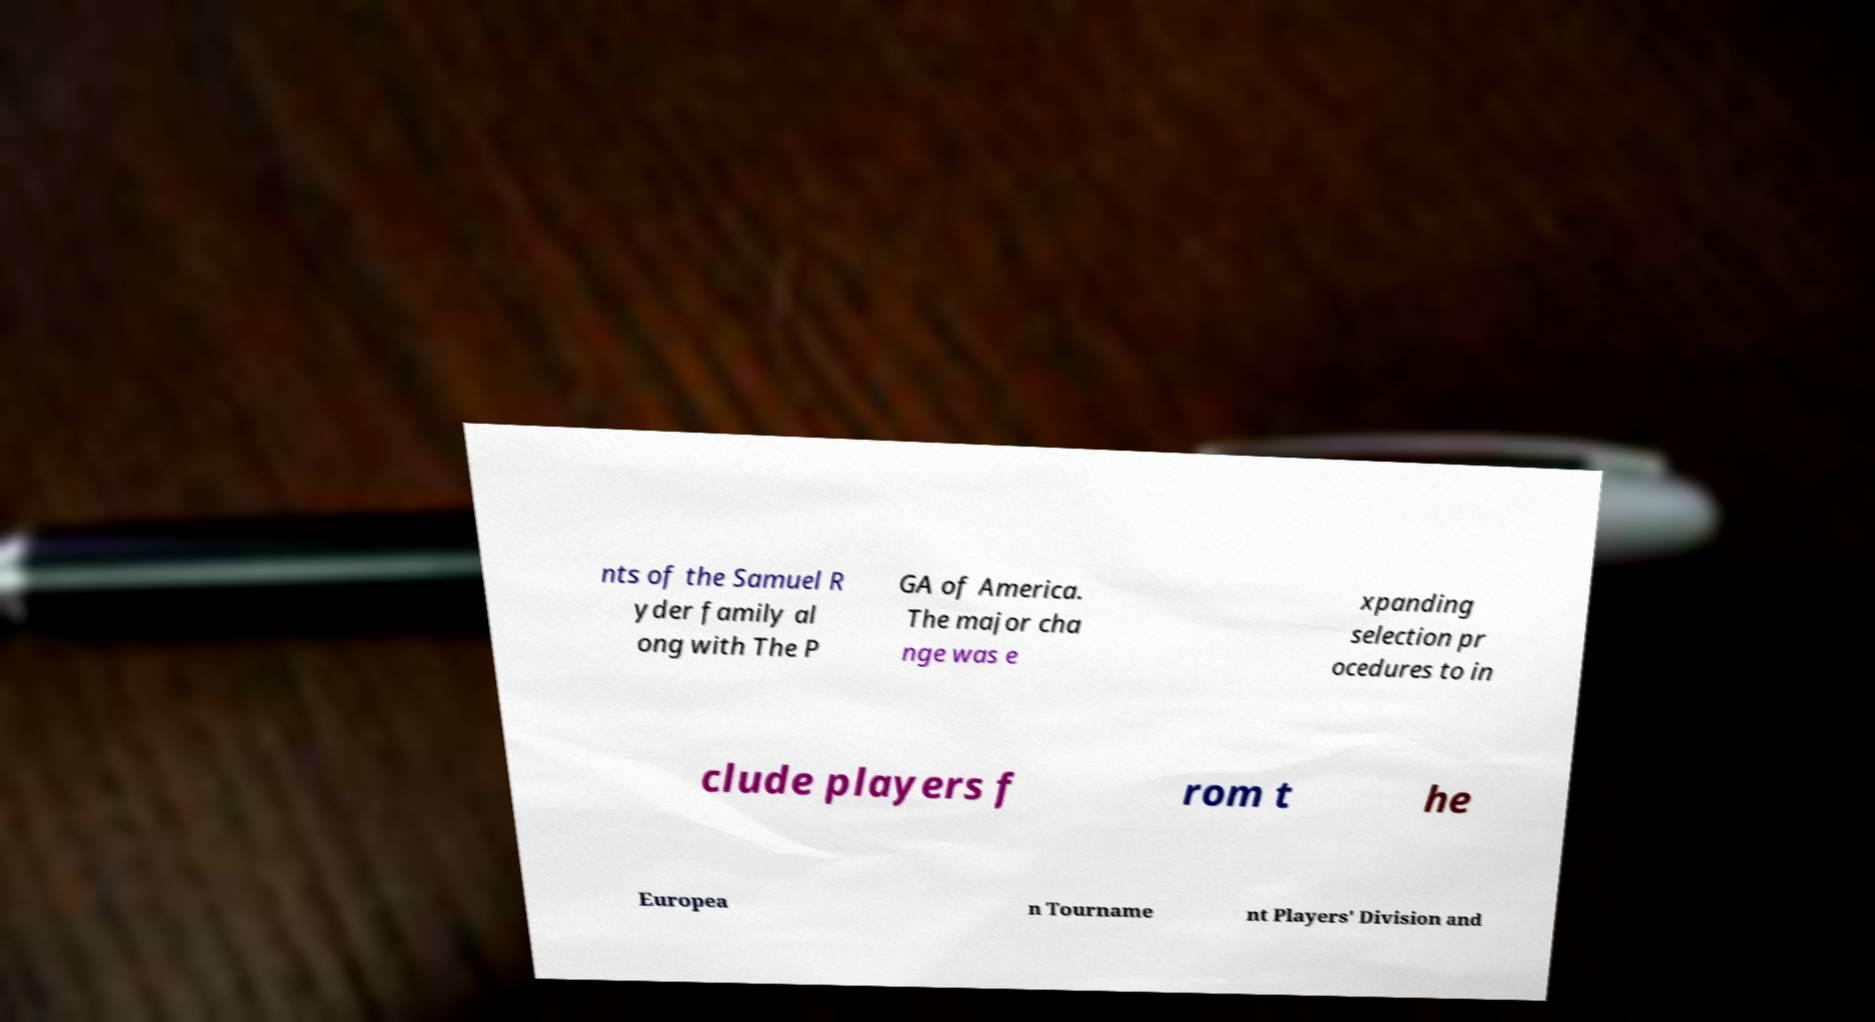Please identify and transcribe the text found in this image. nts of the Samuel R yder family al ong with The P GA of America. The major cha nge was e xpanding selection pr ocedures to in clude players f rom t he Europea n Tourname nt Players' Division and 